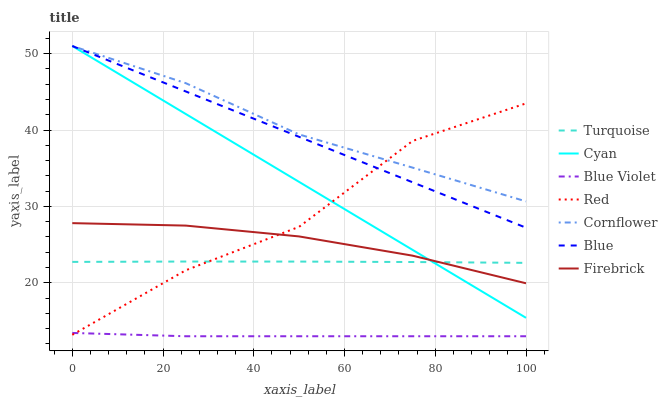Does Blue Violet have the minimum area under the curve?
Answer yes or no. Yes. Does Cornflower have the maximum area under the curve?
Answer yes or no. Yes. Does Turquoise have the minimum area under the curve?
Answer yes or no. No. Does Turquoise have the maximum area under the curve?
Answer yes or no. No. Is Cyan the smoothest?
Answer yes or no. Yes. Is Red the roughest?
Answer yes or no. Yes. Is Cornflower the smoothest?
Answer yes or no. No. Is Cornflower the roughest?
Answer yes or no. No. Does Blue Violet have the lowest value?
Answer yes or no. Yes. Does Turquoise have the lowest value?
Answer yes or no. No. Does Cyan have the highest value?
Answer yes or no. Yes. Does Turquoise have the highest value?
Answer yes or no. No. Is Blue Violet less than Turquoise?
Answer yes or no. Yes. Is Blue greater than Blue Violet?
Answer yes or no. Yes. Does Red intersect Cyan?
Answer yes or no. Yes. Is Red less than Cyan?
Answer yes or no. No. Is Red greater than Cyan?
Answer yes or no. No. Does Blue Violet intersect Turquoise?
Answer yes or no. No. 